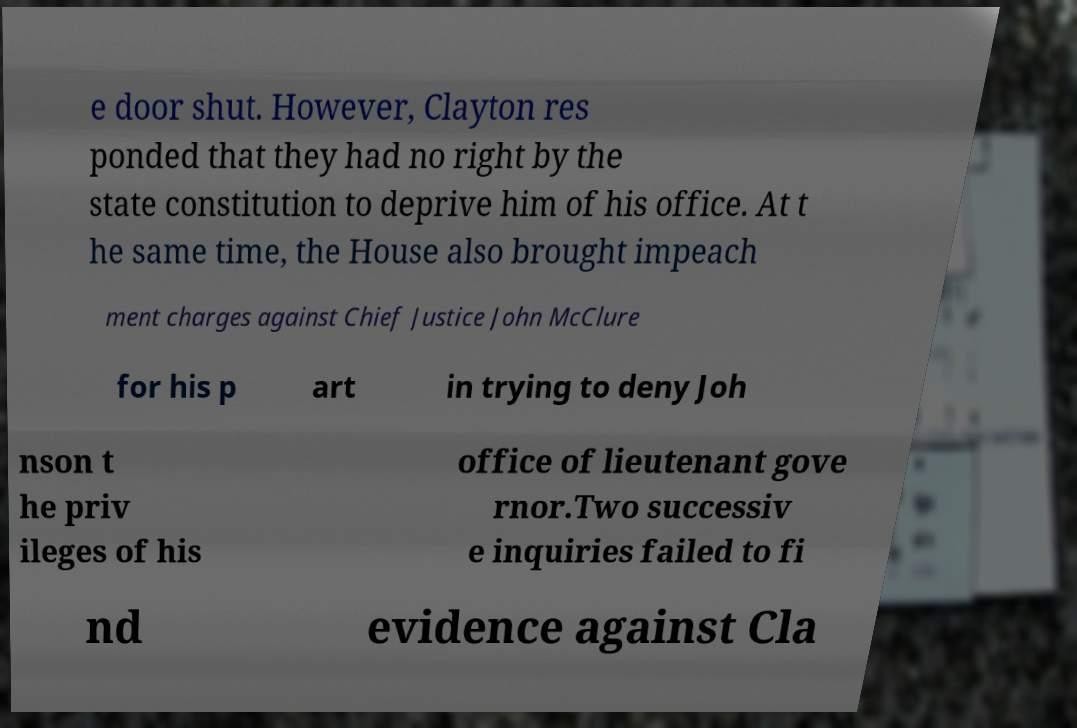Can you accurately transcribe the text from the provided image for me? e door shut. However, Clayton res ponded that they had no right by the state constitution to deprive him of his office. At t he same time, the House also brought impeach ment charges against Chief Justice John McClure for his p art in trying to deny Joh nson t he priv ileges of his office of lieutenant gove rnor.Two successiv e inquiries failed to fi nd evidence against Cla 